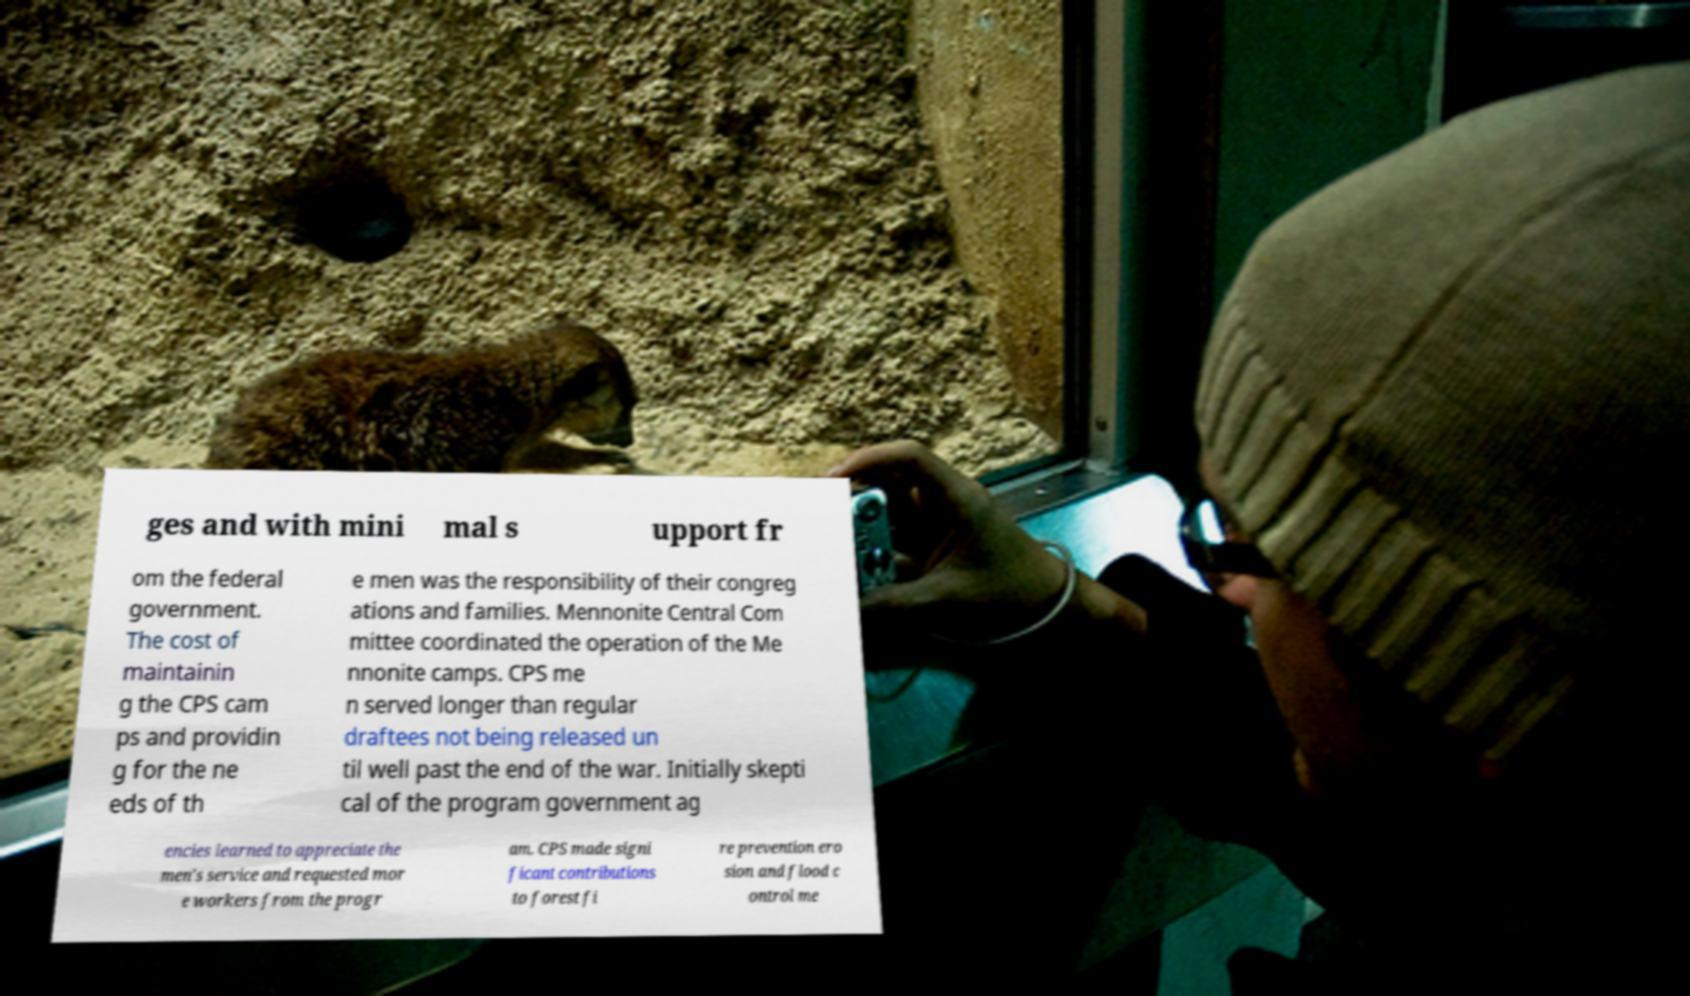Can you read and provide the text displayed in the image?This photo seems to have some interesting text. Can you extract and type it out for me? ges and with mini mal s upport fr om the federal government. The cost of maintainin g the CPS cam ps and providin g for the ne eds of th e men was the responsibility of their congreg ations and families. Mennonite Central Com mittee coordinated the operation of the Me nnonite camps. CPS me n served longer than regular draftees not being released un til well past the end of the war. Initially skepti cal of the program government ag encies learned to appreciate the men's service and requested mor e workers from the progr am. CPS made signi ficant contributions to forest fi re prevention ero sion and flood c ontrol me 